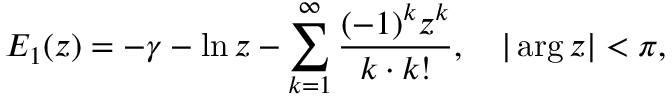<formula> <loc_0><loc_0><loc_500><loc_500>E _ { 1 } ( z ) = - \gamma - \ln z - \sum _ { k = 1 } ^ { \infty } \frac { ( - 1 ) ^ { k } z ^ { k } } { k \cdot k ! } , \quad | \arg z | < \pi { , }</formula> 